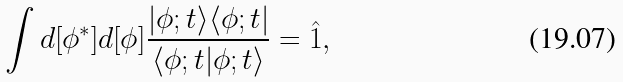Convert formula to latex. <formula><loc_0><loc_0><loc_500><loc_500>\int d [ \phi ^ { * } ] d [ \phi ] \frac { | \phi ; t \rangle \langle \phi ; t | } { \langle \phi ; t | \phi ; t \rangle } = \hat { 1 } ,</formula> 